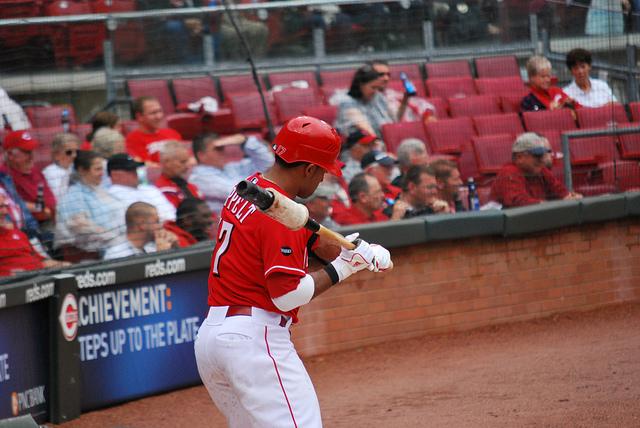What is his name?
Keep it brief. Applet. Whose ballpark is represented here?
Be succinct. Cubs. What is the man holding?
Quick response, please. Bat. Is the player preparing to bat?
Concise answer only. Yes. What is she holding?
Be succinct. Bat. Do you think the player feels a lot of pressure from the crowd?
Short answer required. No. What number is on the players uniform?
Give a very brief answer. 7. What is the player doing?
Give a very brief answer. Batting. 